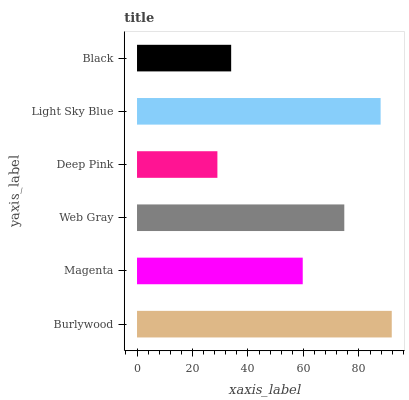Is Deep Pink the minimum?
Answer yes or no. Yes. Is Burlywood the maximum?
Answer yes or no. Yes. Is Magenta the minimum?
Answer yes or no. No. Is Magenta the maximum?
Answer yes or no. No. Is Burlywood greater than Magenta?
Answer yes or no. Yes. Is Magenta less than Burlywood?
Answer yes or no. Yes. Is Magenta greater than Burlywood?
Answer yes or no. No. Is Burlywood less than Magenta?
Answer yes or no. No. Is Web Gray the high median?
Answer yes or no. Yes. Is Magenta the low median?
Answer yes or no. Yes. Is Burlywood the high median?
Answer yes or no. No. Is Web Gray the low median?
Answer yes or no. No. 